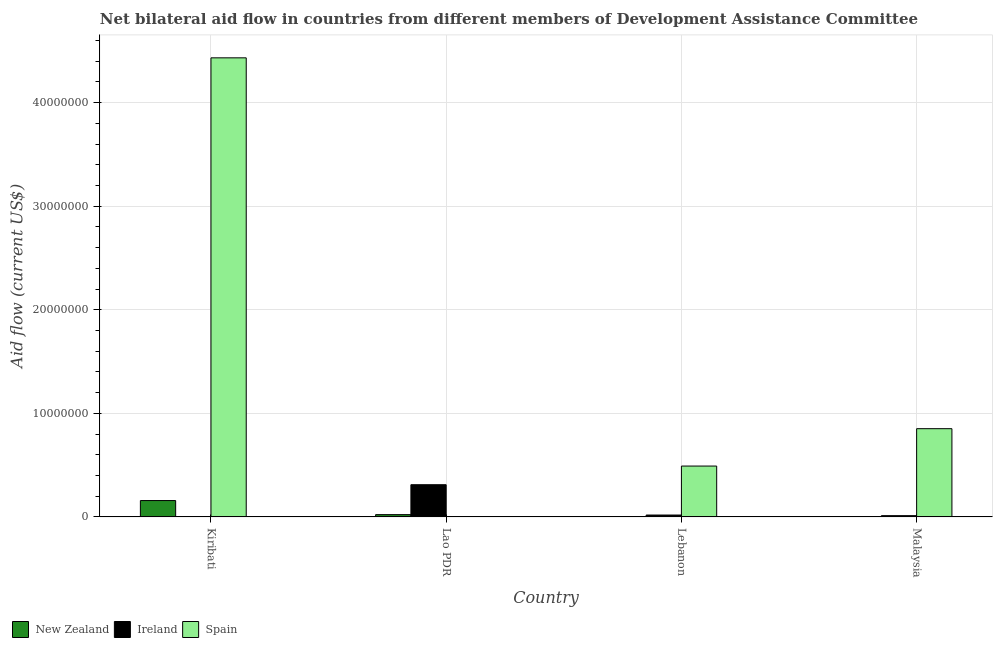How many groups of bars are there?
Provide a succinct answer. 4. Are the number of bars per tick equal to the number of legend labels?
Make the answer very short. No. How many bars are there on the 4th tick from the left?
Give a very brief answer. 3. How many bars are there on the 2nd tick from the right?
Offer a terse response. 3. What is the label of the 4th group of bars from the left?
Ensure brevity in your answer.  Malaysia. In how many cases, is the number of bars for a given country not equal to the number of legend labels?
Give a very brief answer. 1. What is the amount of aid provided by new zealand in Kiribati?
Your answer should be very brief. 1.58e+06. Across all countries, what is the maximum amount of aid provided by new zealand?
Your response must be concise. 1.58e+06. Across all countries, what is the minimum amount of aid provided by new zealand?
Your response must be concise. 10000. In which country was the amount of aid provided by spain maximum?
Give a very brief answer. Kiribati. What is the total amount of aid provided by spain in the graph?
Offer a very short reply. 5.78e+07. What is the difference between the amount of aid provided by new zealand in Kiribati and that in Lebanon?
Offer a very short reply. 1.57e+06. What is the difference between the amount of aid provided by spain in Malaysia and the amount of aid provided by new zealand in Lao PDR?
Offer a terse response. 8.30e+06. What is the average amount of aid provided by ireland per country?
Offer a terse response. 8.55e+05. What is the difference between the amount of aid provided by ireland and amount of aid provided by new zealand in Lao PDR?
Offer a terse response. 2.89e+06. In how many countries, is the amount of aid provided by ireland greater than 26000000 US$?
Provide a short and direct response. 0. Is the amount of aid provided by spain in Lebanon less than that in Malaysia?
Your answer should be compact. Yes. Is the difference between the amount of aid provided by ireland in Kiribati and Lebanon greater than the difference between the amount of aid provided by spain in Kiribati and Lebanon?
Keep it short and to the point. No. What is the difference between the highest and the second highest amount of aid provided by new zealand?
Keep it short and to the point. 1.36e+06. What is the difference between the highest and the lowest amount of aid provided by spain?
Make the answer very short. 4.43e+07. Is the sum of the amount of aid provided by new zealand in Kiribati and Lao PDR greater than the maximum amount of aid provided by spain across all countries?
Provide a short and direct response. No. Is it the case that in every country, the sum of the amount of aid provided by new zealand and amount of aid provided by ireland is greater than the amount of aid provided by spain?
Provide a succinct answer. No. Are all the bars in the graph horizontal?
Offer a terse response. No. How many countries are there in the graph?
Provide a short and direct response. 4. What is the difference between two consecutive major ticks on the Y-axis?
Ensure brevity in your answer.  1.00e+07. Are the values on the major ticks of Y-axis written in scientific E-notation?
Make the answer very short. No. Does the graph contain any zero values?
Your answer should be compact. Yes. Does the graph contain grids?
Provide a succinct answer. Yes. Where does the legend appear in the graph?
Keep it short and to the point. Bottom left. How many legend labels are there?
Give a very brief answer. 3. What is the title of the graph?
Provide a short and direct response. Net bilateral aid flow in countries from different members of Development Assistance Committee. Does "Resident buildings and public services" appear as one of the legend labels in the graph?
Keep it short and to the point. No. What is the label or title of the X-axis?
Keep it short and to the point. Country. What is the Aid flow (current US$) in New Zealand in Kiribati?
Offer a very short reply. 1.58e+06. What is the Aid flow (current US$) in Ireland in Kiribati?
Give a very brief answer. 10000. What is the Aid flow (current US$) in Spain in Kiribati?
Provide a succinct answer. 4.43e+07. What is the Aid flow (current US$) in Ireland in Lao PDR?
Offer a very short reply. 3.11e+06. What is the Aid flow (current US$) of Ireland in Lebanon?
Provide a succinct answer. 1.80e+05. What is the Aid flow (current US$) in Spain in Lebanon?
Your answer should be very brief. 4.91e+06. What is the Aid flow (current US$) in Spain in Malaysia?
Offer a terse response. 8.52e+06. Across all countries, what is the maximum Aid flow (current US$) of New Zealand?
Your response must be concise. 1.58e+06. Across all countries, what is the maximum Aid flow (current US$) in Ireland?
Provide a short and direct response. 3.11e+06. Across all countries, what is the maximum Aid flow (current US$) in Spain?
Offer a very short reply. 4.43e+07. Across all countries, what is the minimum Aid flow (current US$) of New Zealand?
Offer a very short reply. 10000. Across all countries, what is the minimum Aid flow (current US$) in Ireland?
Your response must be concise. 10000. Across all countries, what is the minimum Aid flow (current US$) of Spain?
Ensure brevity in your answer.  0. What is the total Aid flow (current US$) of New Zealand in the graph?
Your answer should be very brief. 1.82e+06. What is the total Aid flow (current US$) of Ireland in the graph?
Provide a succinct answer. 3.42e+06. What is the total Aid flow (current US$) in Spain in the graph?
Make the answer very short. 5.78e+07. What is the difference between the Aid flow (current US$) in New Zealand in Kiribati and that in Lao PDR?
Provide a short and direct response. 1.36e+06. What is the difference between the Aid flow (current US$) of Ireland in Kiribati and that in Lao PDR?
Offer a very short reply. -3.10e+06. What is the difference between the Aid flow (current US$) of New Zealand in Kiribati and that in Lebanon?
Your answer should be very brief. 1.57e+06. What is the difference between the Aid flow (current US$) in Ireland in Kiribati and that in Lebanon?
Make the answer very short. -1.70e+05. What is the difference between the Aid flow (current US$) of Spain in Kiribati and that in Lebanon?
Provide a succinct answer. 3.94e+07. What is the difference between the Aid flow (current US$) of New Zealand in Kiribati and that in Malaysia?
Your answer should be very brief. 1.57e+06. What is the difference between the Aid flow (current US$) of Ireland in Kiribati and that in Malaysia?
Ensure brevity in your answer.  -1.10e+05. What is the difference between the Aid flow (current US$) in Spain in Kiribati and that in Malaysia?
Make the answer very short. 3.58e+07. What is the difference between the Aid flow (current US$) in Ireland in Lao PDR and that in Lebanon?
Make the answer very short. 2.93e+06. What is the difference between the Aid flow (current US$) of Ireland in Lao PDR and that in Malaysia?
Keep it short and to the point. 2.99e+06. What is the difference between the Aid flow (current US$) in Ireland in Lebanon and that in Malaysia?
Make the answer very short. 6.00e+04. What is the difference between the Aid flow (current US$) in Spain in Lebanon and that in Malaysia?
Offer a very short reply. -3.61e+06. What is the difference between the Aid flow (current US$) of New Zealand in Kiribati and the Aid flow (current US$) of Ireland in Lao PDR?
Provide a succinct answer. -1.53e+06. What is the difference between the Aid flow (current US$) in New Zealand in Kiribati and the Aid flow (current US$) in Ireland in Lebanon?
Offer a very short reply. 1.40e+06. What is the difference between the Aid flow (current US$) in New Zealand in Kiribati and the Aid flow (current US$) in Spain in Lebanon?
Your answer should be very brief. -3.33e+06. What is the difference between the Aid flow (current US$) in Ireland in Kiribati and the Aid flow (current US$) in Spain in Lebanon?
Offer a very short reply. -4.90e+06. What is the difference between the Aid flow (current US$) of New Zealand in Kiribati and the Aid flow (current US$) of Ireland in Malaysia?
Your answer should be very brief. 1.46e+06. What is the difference between the Aid flow (current US$) in New Zealand in Kiribati and the Aid flow (current US$) in Spain in Malaysia?
Offer a very short reply. -6.94e+06. What is the difference between the Aid flow (current US$) of Ireland in Kiribati and the Aid flow (current US$) of Spain in Malaysia?
Your answer should be compact. -8.51e+06. What is the difference between the Aid flow (current US$) of New Zealand in Lao PDR and the Aid flow (current US$) of Ireland in Lebanon?
Provide a short and direct response. 4.00e+04. What is the difference between the Aid flow (current US$) of New Zealand in Lao PDR and the Aid flow (current US$) of Spain in Lebanon?
Offer a very short reply. -4.69e+06. What is the difference between the Aid flow (current US$) in Ireland in Lao PDR and the Aid flow (current US$) in Spain in Lebanon?
Offer a terse response. -1.80e+06. What is the difference between the Aid flow (current US$) in New Zealand in Lao PDR and the Aid flow (current US$) in Ireland in Malaysia?
Make the answer very short. 1.00e+05. What is the difference between the Aid flow (current US$) of New Zealand in Lao PDR and the Aid flow (current US$) of Spain in Malaysia?
Offer a terse response. -8.30e+06. What is the difference between the Aid flow (current US$) in Ireland in Lao PDR and the Aid flow (current US$) in Spain in Malaysia?
Provide a short and direct response. -5.41e+06. What is the difference between the Aid flow (current US$) in New Zealand in Lebanon and the Aid flow (current US$) in Ireland in Malaysia?
Offer a very short reply. -1.10e+05. What is the difference between the Aid flow (current US$) in New Zealand in Lebanon and the Aid flow (current US$) in Spain in Malaysia?
Offer a terse response. -8.51e+06. What is the difference between the Aid flow (current US$) of Ireland in Lebanon and the Aid flow (current US$) of Spain in Malaysia?
Keep it short and to the point. -8.34e+06. What is the average Aid flow (current US$) in New Zealand per country?
Offer a terse response. 4.55e+05. What is the average Aid flow (current US$) in Ireland per country?
Ensure brevity in your answer.  8.55e+05. What is the average Aid flow (current US$) in Spain per country?
Offer a very short reply. 1.44e+07. What is the difference between the Aid flow (current US$) in New Zealand and Aid flow (current US$) in Ireland in Kiribati?
Provide a succinct answer. 1.57e+06. What is the difference between the Aid flow (current US$) in New Zealand and Aid flow (current US$) in Spain in Kiribati?
Make the answer very short. -4.28e+07. What is the difference between the Aid flow (current US$) in Ireland and Aid flow (current US$) in Spain in Kiribati?
Your answer should be compact. -4.43e+07. What is the difference between the Aid flow (current US$) in New Zealand and Aid flow (current US$) in Ireland in Lao PDR?
Your answer should be very brief. -2.89e+06. What is the difference between the Aid flow (current US$) in New Zealand and Aid flow (current US$) in Spain in Lebanon?
Provide a short and direct response. -4.90e+06. What is the difference between the Aid flow (current US$) in Ireland and Aid flow (current US$) in Spain in Lebanon?
Keep it short and to the point. -4.73e+06. What is the difference between the Aid flow (current US$) of New Zealand and Aid flow (current US$) of Spain in Malaysia?
Offer a terse response. -8.51e+06. What is the difference between the Aid flow (current US$) of Ireland and Aid flow (current US$) of Spain in Malaysia?
Keep it short and to the point. -8.40e+06. What is the ratio of the Aid flow (current US$) in New Zealand in Kiribati to that in Lao PDR?
Provide a short and direct response. 7.18. What is the ratio of the Aid flow (current US$) in Ireland in Kiribati to that in Lao PDR?
Your answer should be compact. 0. What is the ratio of the Aid flow (current US$) in New Zealand in Kiribati to that in Lebanon?
Offer a terse response. 158. What is the ratio of the Aid flow (current US$) in Ireland in Kiribati to that in Lebanon?
Give a very brief answer. 0.06. What is the ratio of the Aid flow (current US$) of Spain in Kiribati to that in Lebanon?
Offer a very short reply. 9.03. What is the ratio of the Aid flow (current US$) in New Zealand in Kiribati to that in Malaysia?
Give a very brief answer. 158. What is the ratio of the Aid flow (current US$) in Ireland in Kiribati to that in Malaysia?
Provide a succinct answer. 0.08. What is the ratio of the Aid flow (current US$) of Spain in Kiribati to that in Malaysia?
Give a very brief answer. 5.2. What is the ratio of the Aid flow (current US$) of New Zealand in Lao PDR to that in Lebanon?
Offer a very short reply. 22. What is the ratio of the Aid flow (current US$) of Ireland in Lao PDR to that in Lebanon?
Provide a succinct answer. 17.28. What is the ratio of the Aid flow (current US$) of Ireland in Lao PDR to that in Malaysia?
Provide a succinct answer. 25.92. What is the ratio of the Aid flow (current US$) in New Zealand in Lebanon to that in Malaysia?
Your answer should be very brief. 1. What is the ratio of the Aid flow (current US$) of Spain in Lebanon to that in Malaysia?
Your answer should be very brief. 0.58. What is the difference between the highest and the second highest Aid flow (current US$) of New Zealand?
Your response must be concise. 1.36e+06. What is the difference between the highest and the second highest Aid flow (current US$) of Ireland?
Your answer should be very brief. 2.93e+06. What is the difference between the highest and the second highest Aid flow (current US$) in Spain?
Give a very brief answer. 3.58e+07. What is the difference between the highest and the lowest Aid flow (current US$) of New Zealand?
Provide a short and direct response. 1.57e+06. What is the difference between the highest and the lowest Aid flow (current US$) in Ireland?
Your response must be concise. 3.10e+06. What is the difference between the highest and the lowest Aid flow (current US$) in Spain?
Keep it short and to the point. 4.43e+07. 